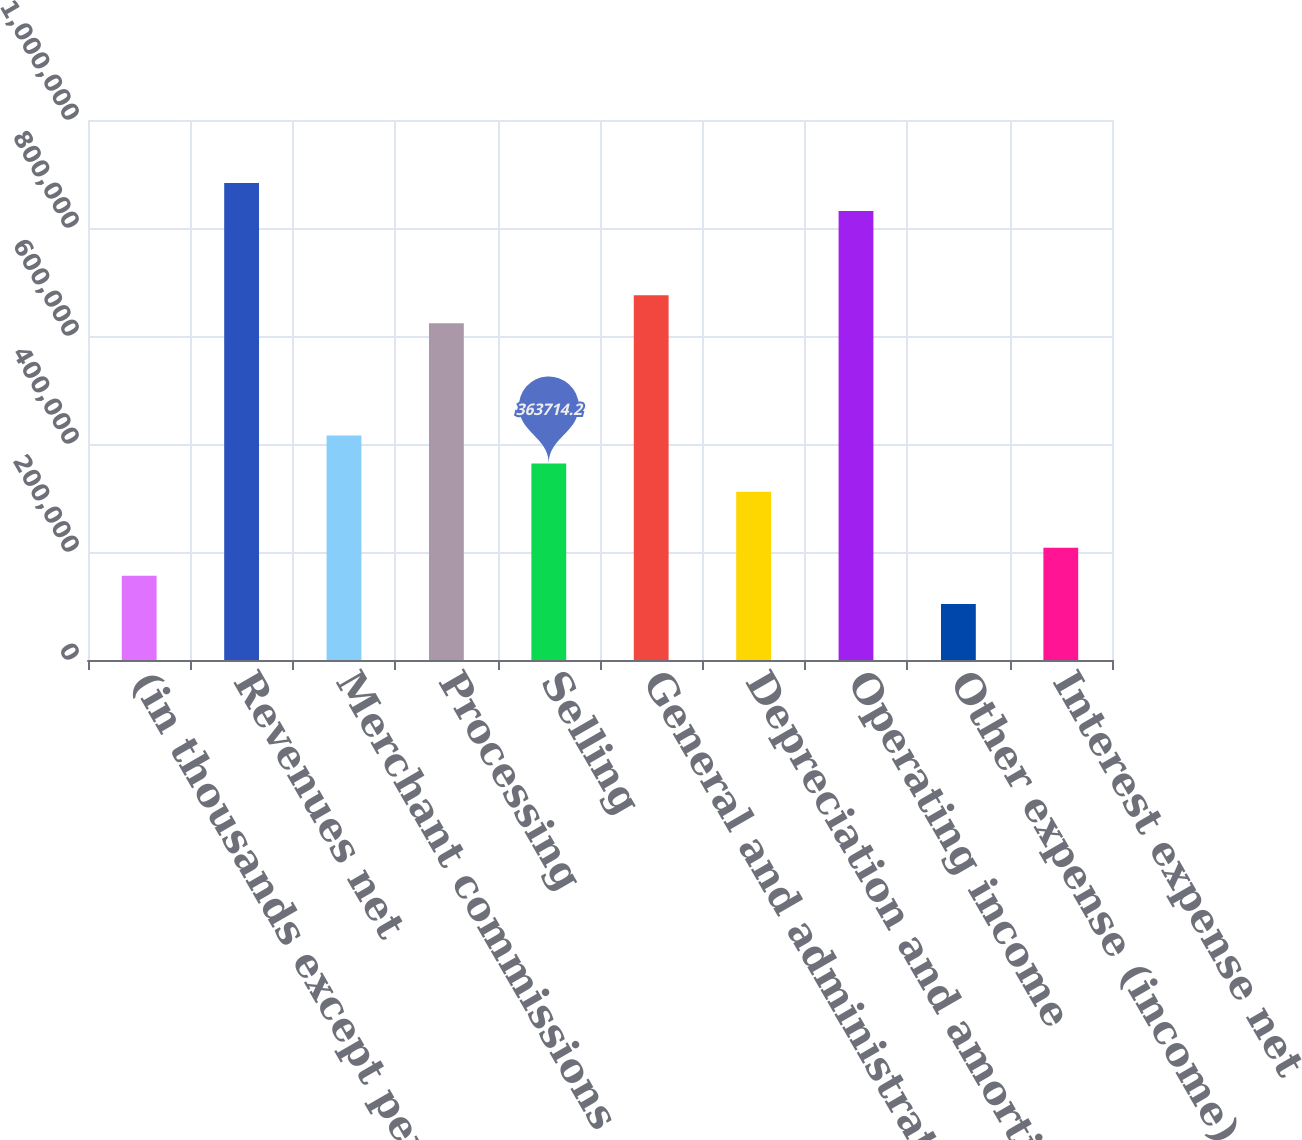Convert chart to OTSL. <chart><loc_0><loc_0><loc_500><loc_500><bar_chart><fcel>(in thousands except per share<fcel>Revenues net<fcel>Merchant commissions<fcel>Processing<fcel>Selling<fcel>General and administrative<fcel>Depreciation and amortization<fcel>Operating income<fcel>Other expense (income) net<fcel>Interest expense net<nl><fcel>155879<fcel>883303<fcel>415673<fcel>623509<fcel>363714<fcel>675468<fcel>311755<fcel>831344<fcel>103920<fcel>207837<nl></chart> 